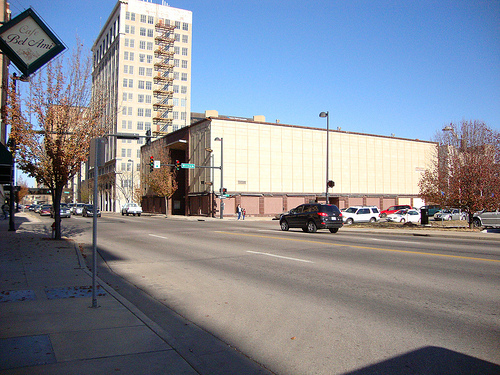<image>
Is there a white car next to the building? No. The white car is not positioned next to the building. They are located in different areas of the scene. Is the sign on the building? No. The sign is not positioned on the building. They may be near each other, but the sign is not supported by or resting on top of the building. 